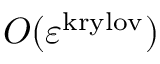<formula> <loc_0><loc_0><loc_500><loc_500>O ( \varepsilon ^ { k r y l o v } )</formula> 